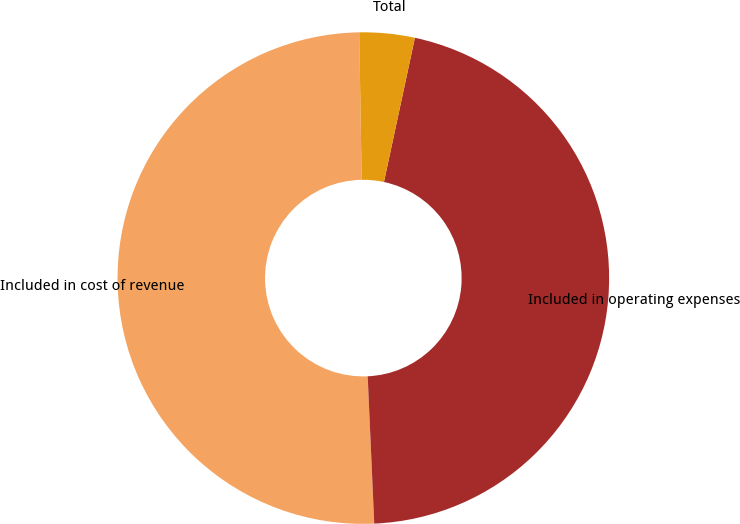Convert chart to OTSL. <chart><loc_0><loc_0><loc_500><loc_500><pie_chart><fcel>Included in cost of revenue<fcel>Included in operating expenses<fcel>Total<nl><fcel>50.44%<fcel>45.93%<fcel>3.63%<nl></chart> 